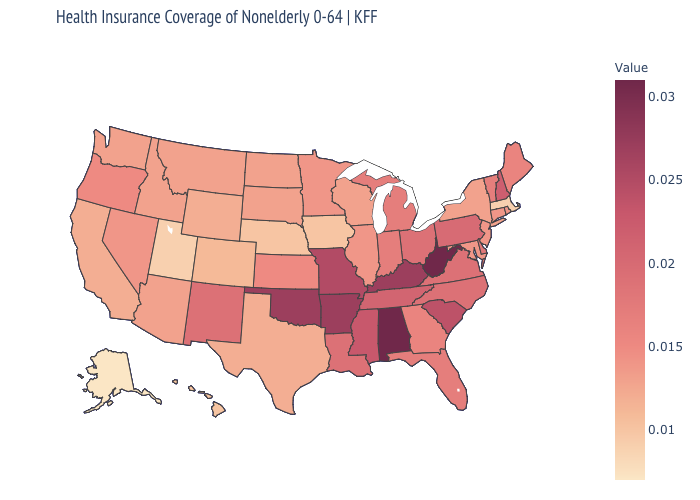Which states have the highest value in the USA?
Answer briefly. Alabama, West Virginia. Does the map have missing data?
Keep it brief. No. Which states have the highest value in the USA?
Write a very short answer. Alabama, West Virginia. Among the states that border North Dakota , which have the lowest value?
Quick response, please. Montana, South Dakota. Does Massachusetts have the lowest value in the Northeast?
Be succinct. Yes. Does Hawaii have a lower value than Alaska?
Quick response, please. No. Which states have the highest value in the USA?
Give a very brief answer. Alabama, West Virginia. Which states hav the highest value in the West?
Write a very short answer. New Mexico. 